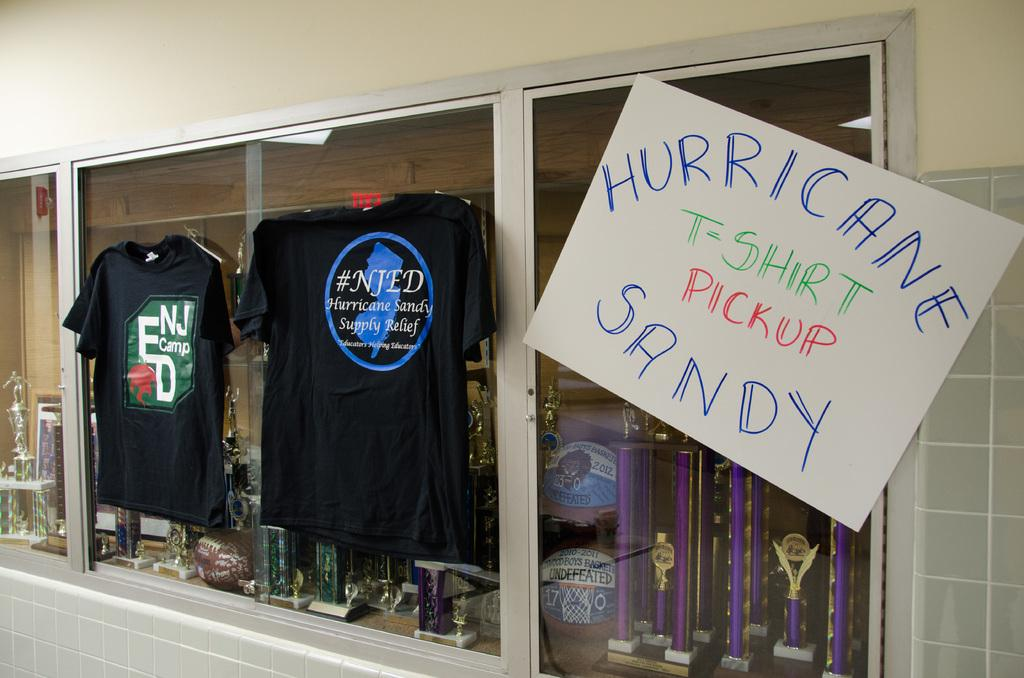<image>
Render a clear and concise summary of the photo. a store with a hurricane label in the front of it 